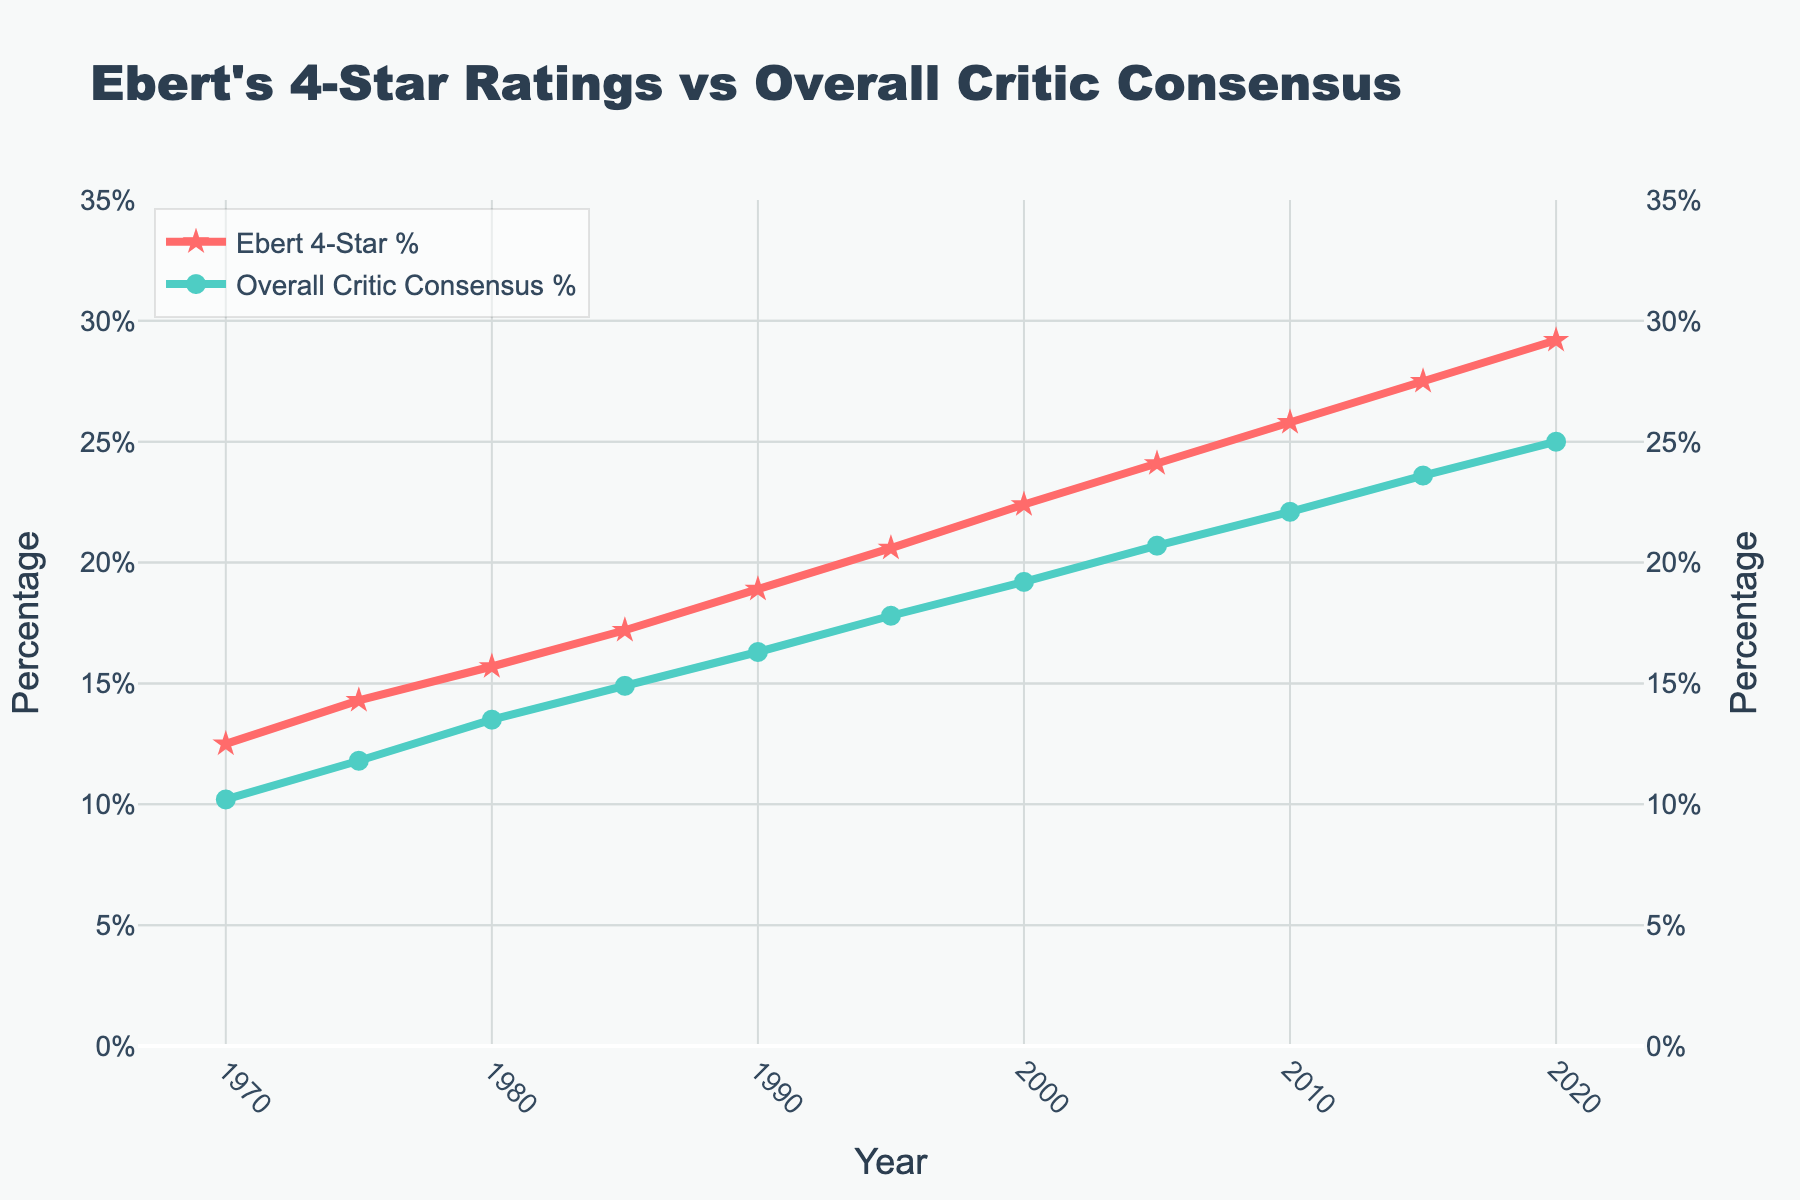What was the percentage difference between Ebert's 4-Star ratings and the overall critic consensus in 2020? In 2020, Ebert's 4-Star % was 29.2%, and the overall critic consensus % was 25.0%. The difference is 29.2% - 25.0% = 4.2%.
Answer: 4.2% In which year did Ebert's 4-Star ratings first surpass 20%? The plot shows that Ebert's 4-Star ratings first surpassed 20% in the year 1995, which had a percentage of 20.6%.
Answer: 1995 Compare the growth trend of Ebert's 4-Star ratings and the overall critic consensus from 1970 to 2020. Which had a steeper increase? Ebert's 4-Star ratings started at 12.5% in 1970 and rose to 29.2% in 2020, a total increase of 16.7 percentage points. The overall critic consensus started at 10.2% and increased to 25.0%, a total increase of 14.8 percentage points. Ebert's ratings had a steeper increase.
Answer: Ebert's 4-Star ratings What is the average percentage of Ebert's 4-Star ratings over the decades provided? Sum of Ebert's 4-Star % over the years: 12.5 + 14.3 + 15.7 + 17.2 + 18.9 + 20.6 + 22.4 + 24.1 + 25.8 + 27.5 + 29.2 = 228.2. Number of years = 11. Thus, the average is 228.2 / 11 ≈ 20.75%.
Answer: 20.75% In what year did the overall critic consensus reach at least 20%, and how much below Ebert's percentage was it at that time? The overall critic consensus first reached at least 20% in 2005. In that year, the overall critic consensus was 20.7%, and Ebert's 4-Star % was 24.1%. The difference is 24.1% - 20.7% = 3.4%.
Answer: 2005, 3.4% What is the percentage increase of Ebert's 4-Star ratings from 1980 to 2010? Ebert's 4-Star ratings were 15.7% in 1980 and 25.8% in 2010. The percentage increase is ((25.8 - 15.7) / 15.7) × 100 = 64.33%.
Answer: 64.33% Which year shows the smallest gap between Ebert's and the overall critic consensus percentages? What is the value of that gap? In 1970, the gap between Ebert's 4-Star % (12.5%) and the overall critic consensus % (10.2%) is the smallest: 12.5% - 10.2% = 2.3%.
Answer: 1970, 2.3% How much did the overall critic consensus ratings grow from 1990 to 2020? The overall critic consensus was 16.3% in 1990 and 25.0% in 2020. The growth is 25.0% - 16.3% = 8.7%.
Answer: 8.7% How many years show Ebert's 4-Star ratings above 25%? From the data, Ebert's 4-Star ratings were above 25% in 2010 (25.8%), 2015 (27.5%), and 2020 (29.2%). Therefore, there are 3 years.
Answer: 3 